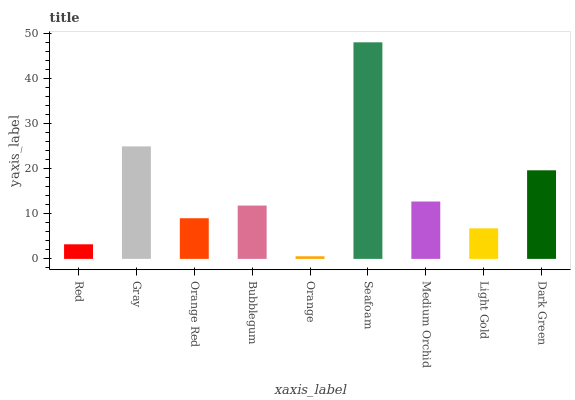Is Orange the minimum?
Answer yes or no. Yes. Is Seafoam the maximum?
Answer yes or no. Yes. Is Gray the minimum?
Answer yes or no. No. Is Gray the maximum?
Answer yes or no. No. Is Gray greater than Red?
Answer yes or no. Yes. Is Red less than Gray?
Answer yes or no. Yes. Is Red greater than Gray?
Answer yes or no. No. Is Gray less than Red?
Answer yes or no. No. Is Bubblegum the high median?
Answer yes or no. Yes. Is Bubblegum the low median?
Answer yes or no. Yes. Is Gray the high median?
Answer yes or no. No. Is Light Gold the low median?
Answer yes or no. No. 